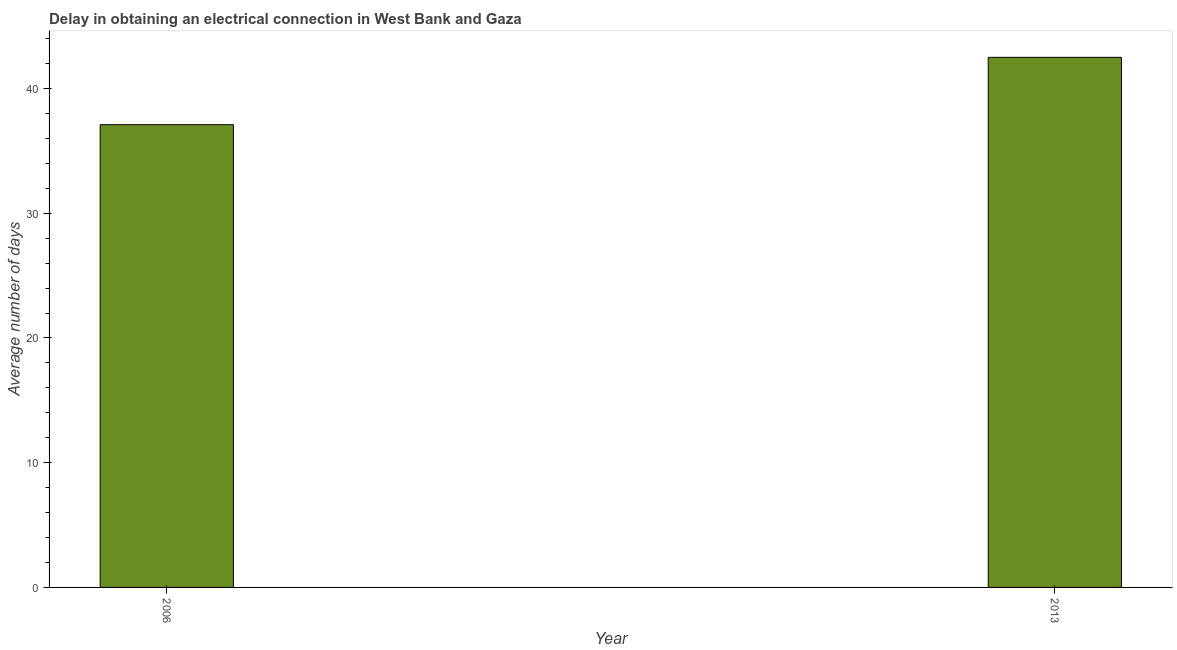Does the graph contain grids?
Provide a short and direct response. No. What is the title of the graph?
Provide a short and direct response. Delay in obtaining an electrical connection in West Bank and Gaza. What is the label or title of the X-axis?
Provide a short and direct response. Year. What is the label or title of the Y-axis?
Ensure brevity in your answer.  Average number of days. What is the dalay in electrical connection in 2006?
Give a very brief answer. 37.1. Across all years, what is the maximum dalay in electrical connection?
Your answer should be compact. 42.5. Across all years, what is the minimum dalay in electrical connection?
Offer a terse response. 37.1. In which year was the dalay in electrical connection maximum?
Keep it short and to the point. 2013. In which year was the dalay in electrical connection minimum?
Keep it short and to the point. 2006. What is the sum of the dalay in electrical connection?
Make the answer very short. 79.6. What is the difference between the dalay in electrical connection in 2006 and 2013?
Your answer should be very brief. -5.4. What is the average dalay in electrical connection per year?
Give a very brief answer. 39.8. What is the median dalay in electrical connection?
Provide a short and direct response. 39.8. In how many years, is the dalay in electrical connection greater than 26 days?
Give a very brief answer. 2. Do a majority of the years between 2006 and 2013 (inclusive) have dalay in electrical connection greater than 28 days?
Provide a succinct answer. Yes. What is the ratio of the dalay in electrical connection in 2006 to that in 2013?
Provide a succinct answer. 0.87. Is the dalay in electrical connection in 2006 less than that in 2013?
Make the answer very short. Yes. In how many years, is the dalay in electrical connection greater than the average dalay in electrical connection taken over all years?
Your answer should be compact. 1. What is the Average number of days of 2006?
Make the answer very short. 37.1. What is the Average number of days of 2013?
Your response must be concise. 42.5. What is the ratio of the Average number of days in 2006 to that in 2013?
Your response must be concise. 0.87. 